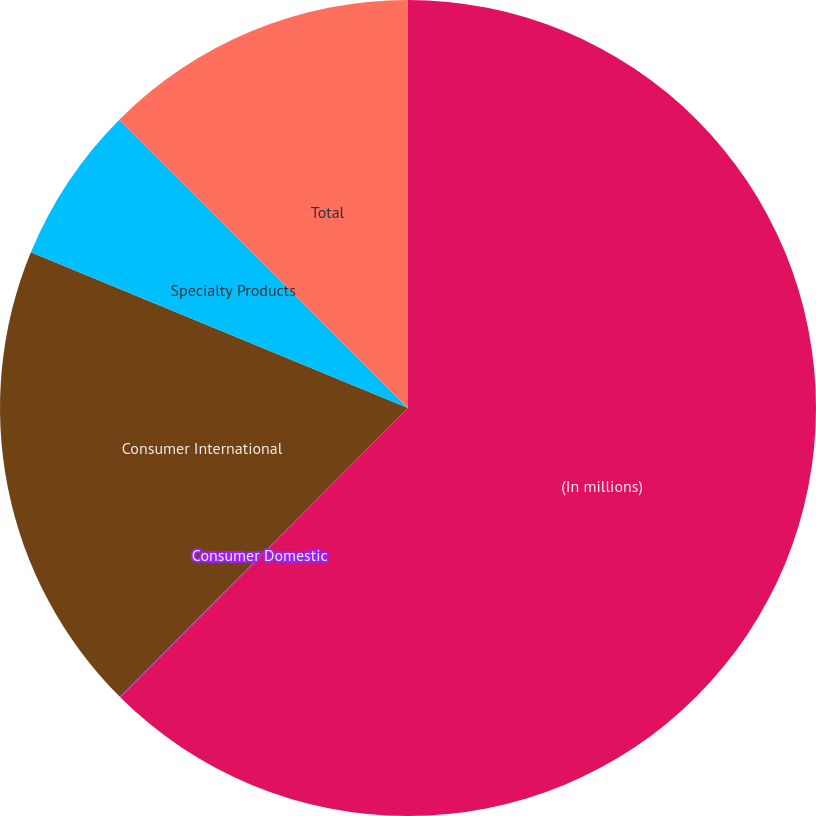Convert chart to OTSL. <chart><loc_0><loc_0><loc_500><loc_500><pie_chart><fcel>(In millions)<fcel>Consumer Domestic<fcel>Consumer International<fcel>Specialty Products<fcel>Total<nl><fcel>62.46%<fcel>0.02%<fcel>18.75%<fcel>6.26%<fcel>12.51%<nl></chart> 